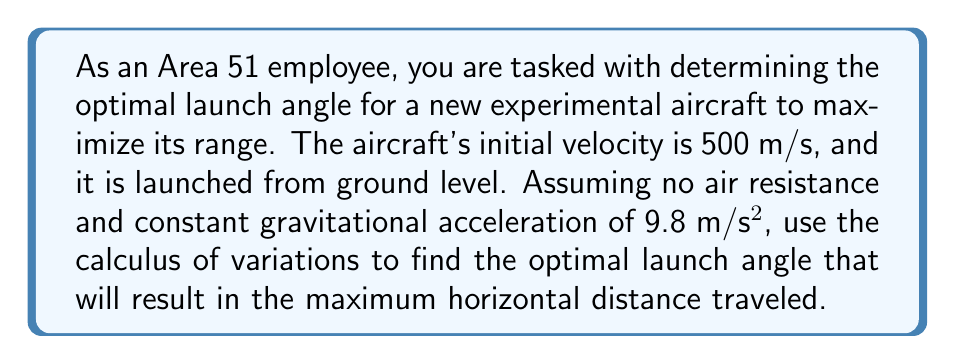Show me your answer to this math problem. To solve this problem, we'll use the calculus of variations approach:

1) First, let's define our variables:
   $v_0$ = initial velocity = 500 m/s
   $g$ = gravitational acceleration = 9.8 m/s²
   $\theta$ = launch angle (to be optimized)

2) The range (horizontal distance) of a projectile launched at an angle $\theta$ is given by:

   $$R = \frac{v_0^2 \sin(2\theta)}{g}$$

3) To find the maximum range, we need to find the value of $\theta$ that maximizes this function. We can do this by taking the derivative with respect to $\theta$ and setting it equal to zero:

   $$\frac{dR}{d\theta} = \frac{v_0^2}{g} \cdot 2\cos(2\theta) = 0$$

4) Solving this equation:
   $2\cos(2\theta) = 0$
   $\cos(2\theta) = 0$

5) The cosine function equals zero when its argument is $\frac{\pi}{2}$ or $\frac{3\pi}{2}$. In this case:

   $2\theta = \frac{\pi}{2}$
   $\theta = \frac{\pi}{4} = 45°$

6) To confirm this is a maximum (not a minimum), we can check the second derivative:

   $$\frac{d^2R}{d\theta^2} = \frac{v_0^2}{g} \cdot (-4\sin(2\theta))$$

   At $\theta = 45°$, this is negative, confirming a maximum.

7) Therefore, the optimal launch angle for maximum range is 45°.

8) We can calculate the maximum range by substituting this angle back into our original equation:

   $$R_{max} = \frac{(500)^2 \sin(2 \cdot 45°)}{9.8} = \frac{250000}{9.8} \approx 25510.2 \text{ meters}$$
Answer: The optimal launch angle for the experimental aircraft to maximize its range is 45°, resulting in a maximum range of approximately 25,510.2 meters. 